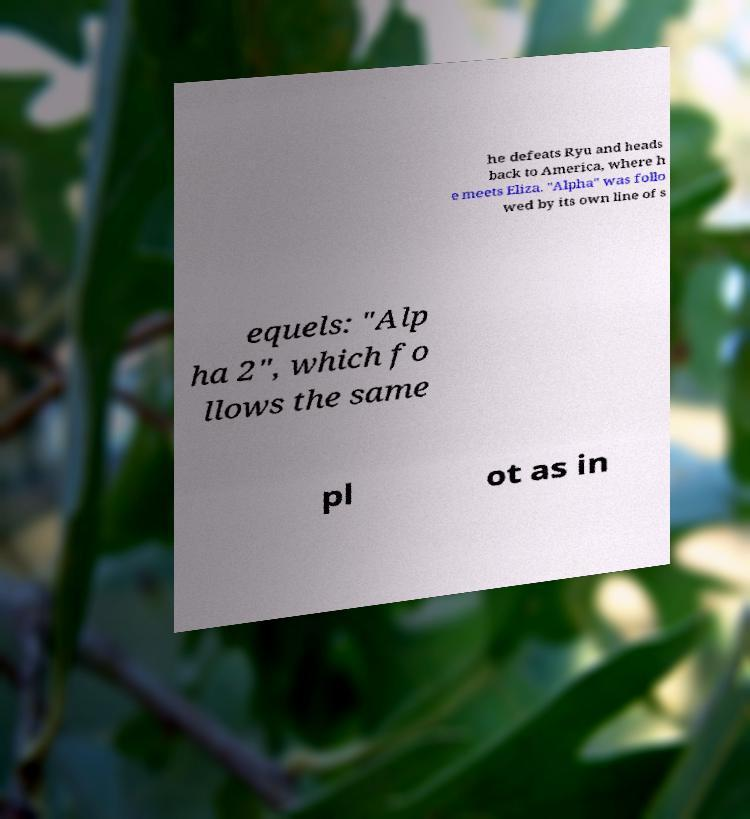Can you read and provide the text displayed in the image?This photo seems to have some interesting text. Can you extract and type it out for me? he defeats Ryu and heads back to America, where h e meets Eliza. "Alpha" was follo wed by its own line of s equels: "Alp ha 2", which fo llows the same pl ot as in 